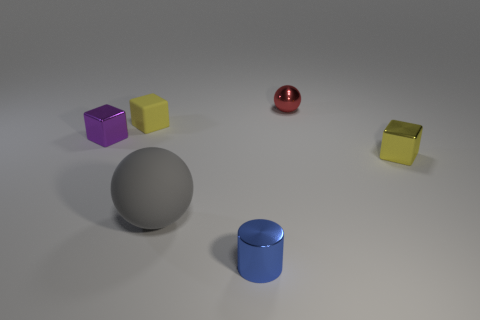What is the shape of the metal thing that is the same color as the tiny rubber thing?
Your answer should be very brief. Cube. There is a small yellow object behind the tiny yellow block that is on the right side of the small red ball; what number of purple shiny things are behind it?
Ensure brevity in your answer.  0. There is a rubber cube that is the same size as the blue metallic object; what color is it?
Offer a terse response. Yellow. There is a yellow object that is in front of the metal object that is to the left of the tiny yellow rubber block; what is its size?
Offer a very short reply. Small. There is another block that is the same color as the tiny matte cube; what size is it?
Give a very brief answer. Small. What number of other things are there of the same size as the rubber ball?
Your answer should be compact. 0. What number of yellow rubber cubes are there?
Ensure brevity in your answer.  1. Is the size of the red thing the same as the purple object?
Offer a very short reply. Yes. What number of other things are there of the same shape as the small yellow metal thing?
Your response must be concise. 2. The yellow cube behind the shiny cube that is to the right of the red metal thing is made of what material?
Your response must be concise. Rubber. 